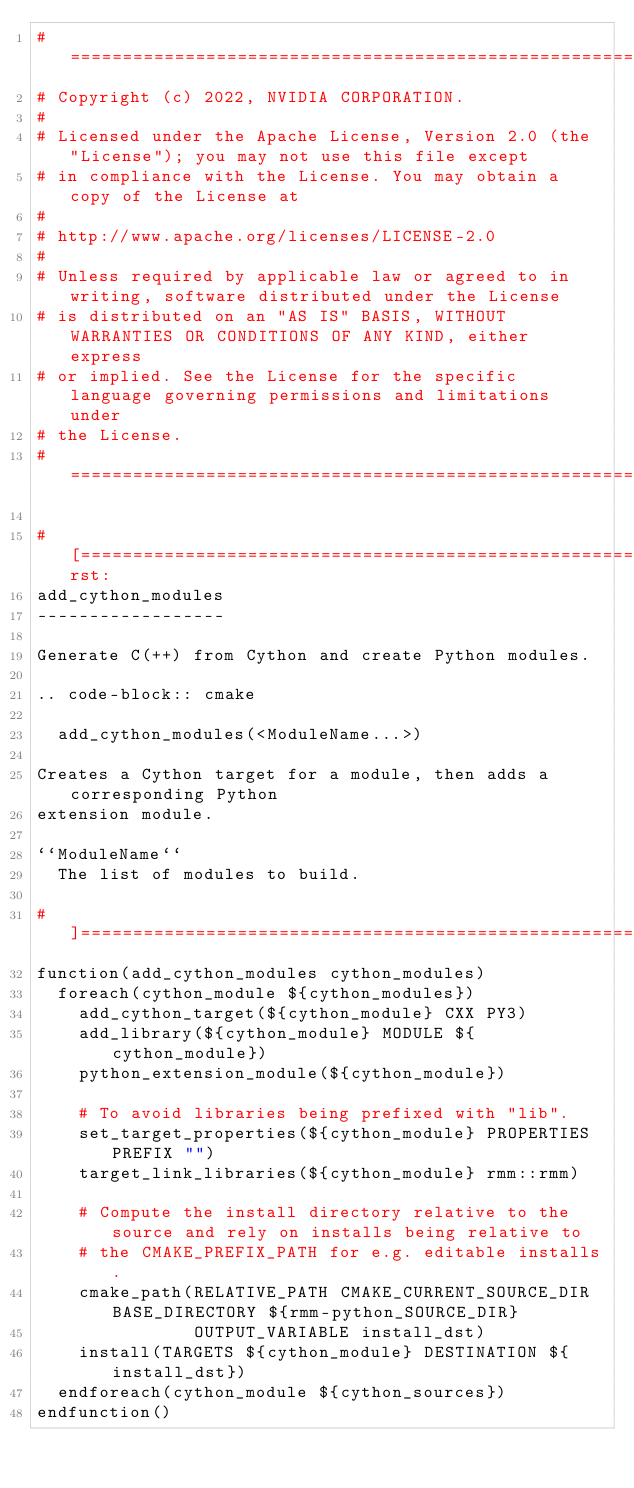<code> <loc_0><loc_0><loc_500><loc_500><_CMake_># =============================================================================
# Copyright (c) 2022, NVIDIA CORPORATION.
#
# Licensed under the Apache License, Version 2.0 (the "License"); you may not use this file except
# in compliance with the License. You may obtain a copy of the License at
#
# http://www.apache.org/licenses/LICENSE-2.0
#
# Unless required by applicable law or agreed to in writing, software distributed under the License
# is distributed on an "AS IS" BASIS, WITHOUT WARRANTIES OR CONDITIONS OF ANY KIND, either express
# or implied. See the License for the specific language governing permissions and limitations under
# the License.
# =============================================================================

#[=======================================================================[.rst:
add_cython_modules
------------------

Generate C(++) from Cython and create Python modules.

.. code-block:: cmake

  add_cython_modules(<ModuleName...>)

Creates a Cython target for a module, then adds a corresponding Python
extension module.

``ModuleName``
  The list of modules to build.

#]=======================================================================]
function(add_cython_modules cython_modules)
  foreach(cython_module ${cython_modules})
    add_cython_target(${cython_module} CXX PY3)
    add_library(${cython_module} MODULE ${cython_module})
    python_extension_module(${cython_module})

    # To avoid libraries being prefixed with "lib".
    set_target_properties(${cython_module} PROPERTIES PREFIX "")
    target_link_libraries(${cython_module} rmm::rmm)

    # Compute the install directory relative to the source and rely on installs being relative to
    # the CMAKE_PREFIX_PATH for e.g. editable installs.
    cmake_path(RELATIVE_PATH CMAKE_CURRENT_SOURCE_DIR BASE_DIRECTORY ${rmm-python_SOURCE_DIR}
               OUTPUT_VARIABLE install_dst)
    install(TARGETS ${cython_module} DESTINATION ${install_dst})
  endforeach(cython_module ${cython_sources})
endfunction()
</code> 